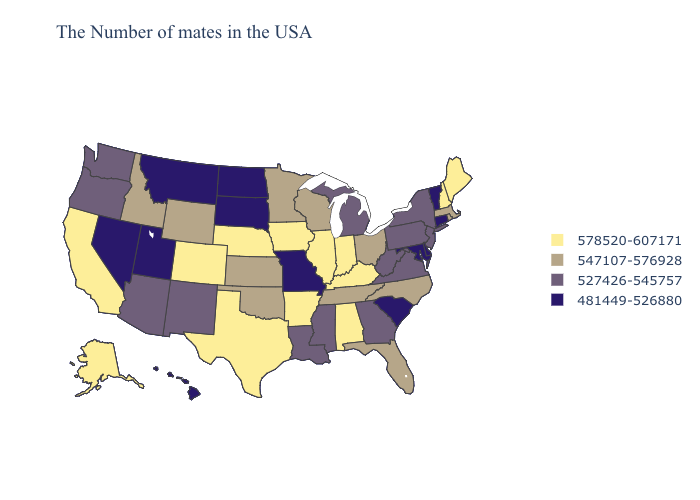Does Wisconsin have the same value as New Mexico?
Give a very brief answer. No. Does the map have missing data?
Give a very brief answer. No. Among the states that border Idaho , does Nevada have the highest value?
Write a very short answer. No. Does Washington have a higher value than Missouri?
Write a very short answer. Yes. Name the states that have a value in the range 578520-607171?
Concise answer only. Maine, New Hampshire, Kentucky, Indiana, Alabama, Illinois, Arkansas, Iowa, Nebraska, Texas, Colorado, California, Alaska. What is the lowest value in the West?
Give a very brief answer. 481449-526880. Which states hav the highest value in the South?
Write a very short answer. Kentucky, Alabama, Arkansas, Texas. What is the value of Kansas?
Answer briefly. 547107-576928. Name the states that have a value in the range 481449-526880?
Answer briefly. Vermont, Connecticut, Delaware, Maryland, South Carolina, Missouri, South Dakota, North Dakota, Utah, Montana, Nevada, Hawaii. Which states hav the highest value in the South?
Keep it brief. Kentucky, Alabama, Arkansas, Texas. Does Maryland have the lowest value in the South?
Concise answer only. Yes. Among the states that border Florida , does Georgia have the lowest value?
Keep it brief. Yes. Which states hav the highest value in the Northeast?
Quick response, please. Maine, New Hampshire. What is the value of Alabama?
Answer briefly. 578520-607171. Name the states that have a value in the range 481449-526880?
Concise answer only. Vermont, Connecticut, Delaware, Maryland, South Carolina, Missouri, South Dakota, North Dakota, Utah, Montana, Nevada, Hawaii. 